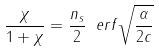<formula> <loc_0><loc_0><loc_500><loc_500>\frac { \chi } { 1 + \chi } = \frac { n _ { s } } { 2 } \ e r f \sqrt { \frac { \alpha } { 2 c } }</formula> 